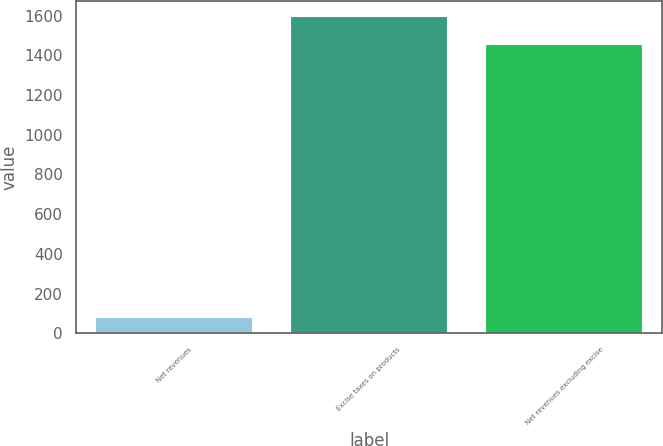Convert chart to OTSL. <chart><loc_0><loc_0><loc_500><loc_500><bar_chart><fcel>Net revenues<fcel>Excise taxes on products<fcel>Net revenues excluding excise<nl><fcel>77<fcel>1595<fcel>1450<nl></chart> 